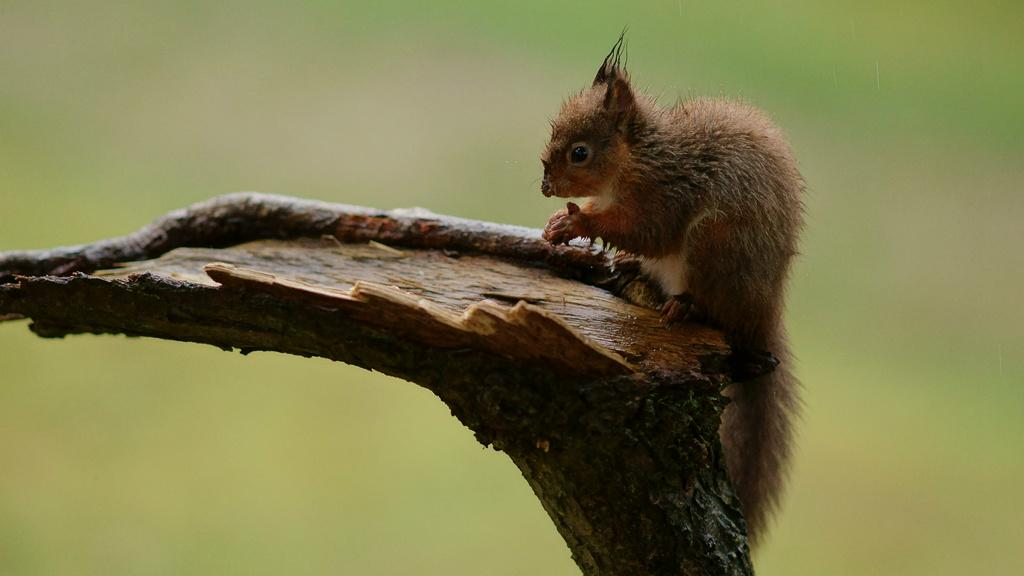What type of creature can be seen in the image? There is an animal in the image. Where is the animal located? The animal is on the branch of a tree. What type of insurance policy does the zebra have in the image? There is no zebra present in the image, and therefore no insurance policy can be discussed. 